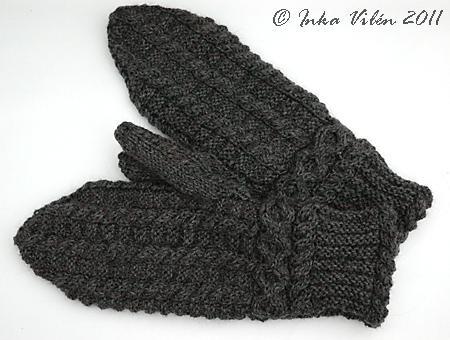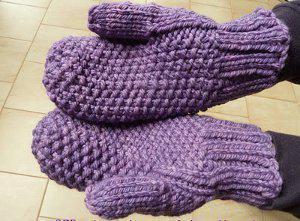The first image is the image on the left, the second image is the image on the right. Considering the images on both sides, is "Solid color mittens appear in each image, a different color and pattern in each one, with one pair worn by a person." valid? Answer yes or no. Yes. The first image is the image on the left, the second image is the image on the right. Assess this claim about the two images: "The person's skin is visible as they try on the gloves.". Correct or not? Answer yes or no. No. 